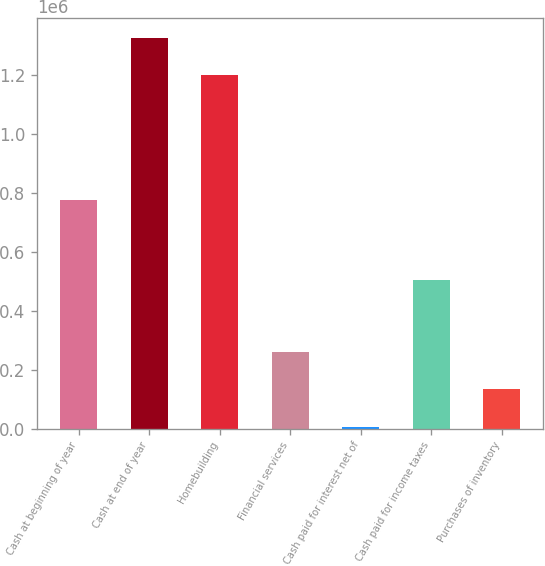<chart> <loc_0><loc_0><loc_500><loc_500><bar_chart><fcel>Cash at beginning of year<fcel>Cash at end of year<fcel>Homebuilding<fcel>Financial services<fcel>Cash paid for interest net of<fcel>Cash paid for income taxes<fcel>Purchases of inventory<nl><fcel>777159<fcel>1.32771e+06<fcel>1.20128e+06<fcel>259422<fcel>6559<fcel>503410<fcel>132990<nl></chart> 